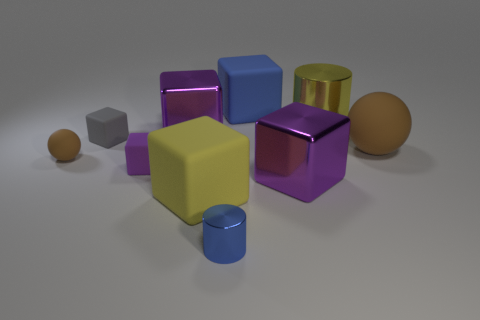What could be the purpose of these objects? They seem to serve an educational or demonstrative purpose, potentially as part of a learning kit for children to understand shapes and colors, or as 3D models for a graphical artist's library. How could these shapes be used in mathematics? In mathematics, these shapes can be used to illustrate concepts such as volume, surface area, and the properties of geometric solids, aiding in spatial reasoning and geometry education. 